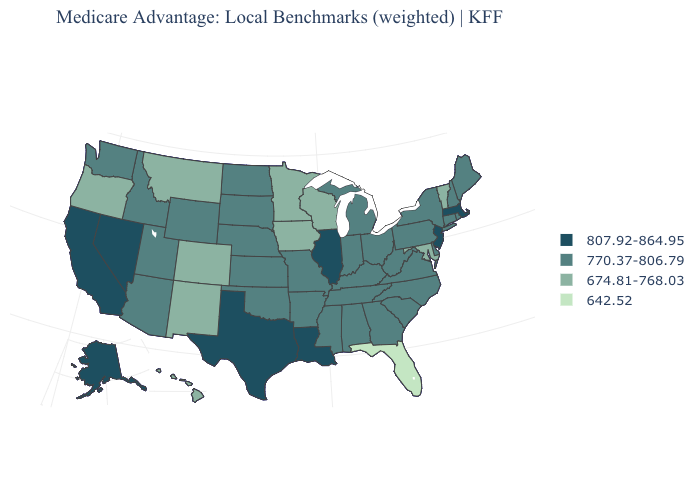Name the states that have a value in the range 674.81-768.03?
Give a very brief answer. Colorado, Hawaii, Iowa, Maryland, Minnesota, Montana, New Mexico, Oregon, Vermont, Wisconsin. What is the value of Wisconsin?
Keep it brief. 674.81-768.03. Name the states that have a value in the range 807.92-864.95?
Quick response, please. Alaska, California, Illinois, Louisiana, Massachusetts, New Jersey, Nevada, Texas. Name the states that have a value in the range 770.37-806.79?
Quick response, please. Alabama, Arkansas, Arizona, Connecticut, Delaware, Georgia, Idaho, Indiana, Kansas, Kentucky, Maine, Michigan, Missouri, Mississippi, North Carolina, North Dakota, Nebraska, New Hampshire, New York, Ohio, Oklahoma, Pennsylvania, Rhode Island, South Carolina, South Dakota, Tennessee, Utah, Virginia, Washington, West Virginia, Wyoming. Name the states that have a value in the range 770.37-806.79?
Write a very short answer. Alabama, Arkansas, Arizona, Connecticut, Delaware, Georgia, Idaho, Indiana, Kansas, Kentucky, Maine, Michigan, Missouri, Mississippi, North Carolina, North Dakota, Nebraska, New Hampshire, New York, Ohio, Oklahoma, Pennsylvania, Rhode Island, South Carolina, South Dakota, Tennessee, Utah, Virginia, Washington, West Virginia, Wyoming. Among the states that border Wisconsin , which have the lowest value?
Quick response, please. Iowa, Minnesota. Name the states that have a value in the range 642.52?
Give a very brief answer. Florida. What is the highest value in states that border North Carolina?
Quick response, please. 770.37-806.79. Which states have the highest value in the USA?
Write a very short answer. Alaska, California, Illinois, Louisiana, Massachusetts, New Jersey, Nevada, Texas. What is the value of Hawaii?
Be succinct. 674.81-768.03. What is the lowest value in the MidWest?
Be succinct. 674.81-768.03. Name the states that have a value in the range 642.52?
Be succinct. Florida. What is the highest value in the USA?
Short answer required. 807.92-864.95. Name the states that have a value in the range 674.81-768.03?
Write a very short answer. Colorado, Hawaii, Iowa, Maryland, Minnesota, Montana, New Mexico, Oregon, Vermont, Wisconsin. 